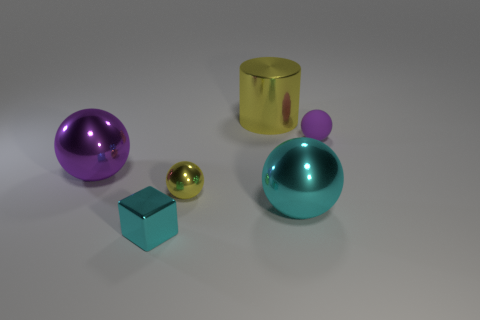What size is the cyan object that is in front of the big cyan metal object?
Your answer should be very brief. Small. How big is the matte thing?
Keep it short and to the point. Small. How many cylinders are small matte objects or small cyan metal things?
Offer a terse response. 0. What is the size of the yellow ball that is the same material as the large purple thing?
Make the answer very short. Small. What number of shiny objects are the same color as the small cube?
Offer a terse response. 1. There is a cyan sphere; are there any cyan blocks to the right of it?
Your answer should be very brief. No. There is a small cyan metal thing; is it the same shape as the purple thing that is on the left side of the tiny matte object?
Your answer should be compact. No. What number of things are either small spheres to the right of the yellow ball or cubes?
Keep it short and to the point. 2. Are there any other things that are the same material as the cylinder?
Offer a terse response. Yes. How many things are both behind the cyan sphere and on the right side of the big yellow shiny cylinder?
Offer a very short reply. 1. 